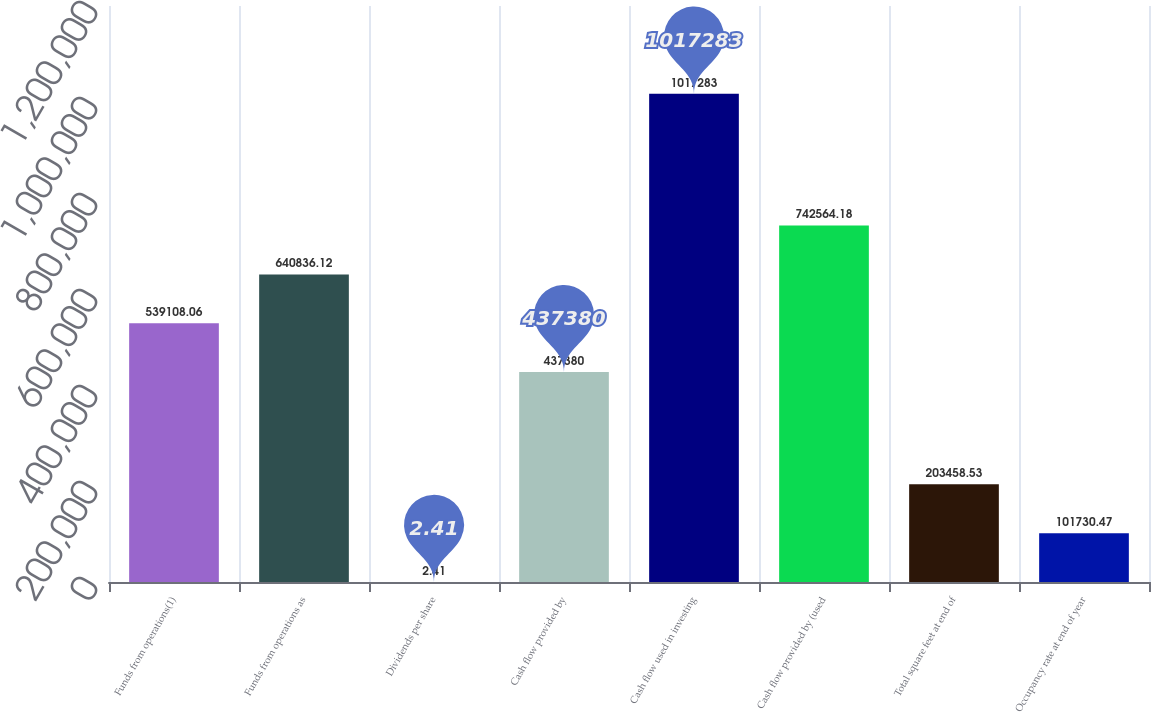Convert chart to OTSL. <chart><loc_0><loc_0><loc_500><loc_500><bar_chart><fcel>Funds from operations(1)<fcel>Funds from operations as<fcel>Dividends per share<fcel>Cash flow provided by<fcel>Cash flow used in investing<fcel>Cash flow provided by (used<fcel>Total square feet at end of<fcel>Occupancy rate at end of year<nl><fcel>539108<fcel>640836<fcel>2.41<fcel>437380<fcel>1.01728e+06<fcel>742564<fcel>203459<fcel>101730<nl></chart> 